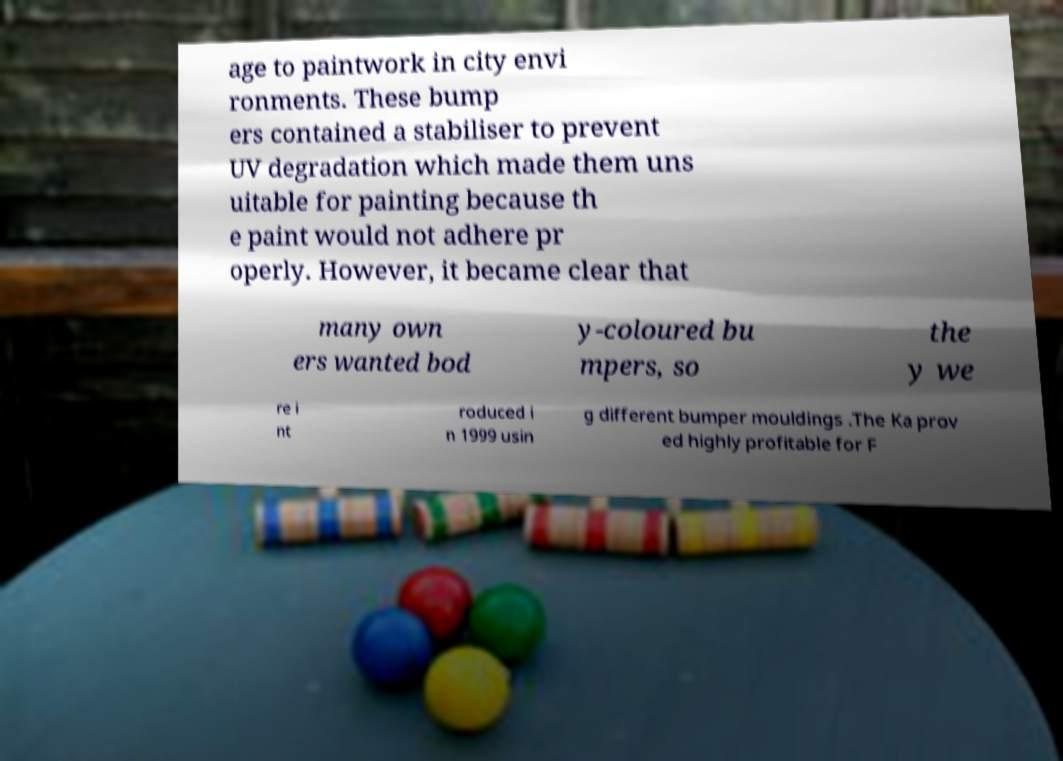Can you accurately transcribe the text from the provided image for me? age to paintwork in city envi ronments. These bump ers contained a stabiliser to prevent UV degradation which made them uns uitable for painting because th e paint would not adhere pr operly. However, it became clear that many own ers wanted bod y-coloured bu mpers, so the y we re i nt roduced i n 1999 usin g different bumper mouldings .The Ka prov ed highly profitable for F 